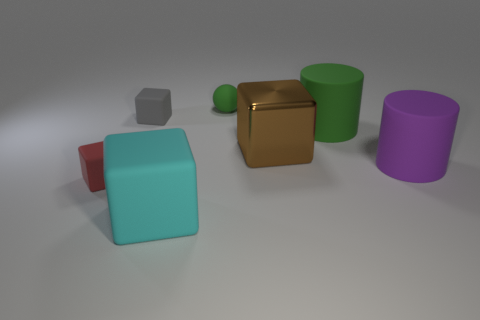Are there the same number of tiny red blocks that are on the right side of the cyan rubber cube and tiny cyan metal cylinders?
Make the answer very short. Yes. Are there any rubber blocks behind the small block behind the purple matte cylinder?
Your answer should be very brief. No. What number of other things are the same color as the matte ball?
Your answer should be very brief. 1. The tiny sphere is what color?
Offer a terse response. Green. There is a matte thing that is right of the brown metallic thing and in front of the large green matte cylinder; what is its size?
Your answer should be compact. Large. How many objects are objects on the right side of the gray object or red cylinders?
Your answer should be very brief. 5. The red object that is the same material as the big green object is what shape?
Make the answer very short. Cube. What is the shape of the large brown thing?
Make the answer very short. Cube. What color is the block that is both in front of the small gray matte block and behind the tiny red matte block?
Offer a very short reply. Brown. The gray matte thing that is the same size as the red thing is what shape?
Your response must be concise. Cube. 